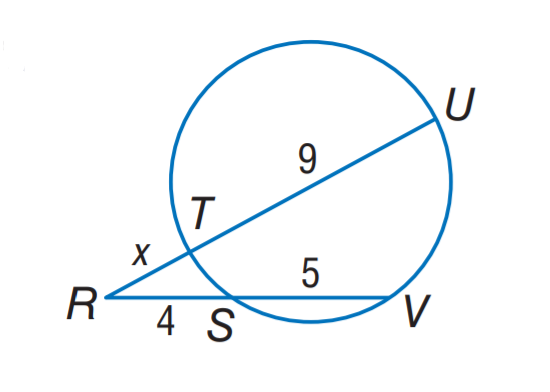Answer the mathemtical geometry problem and directly provide the correct option letter.
Question: Find x.
Choices: A: 2 B: 3 C: 4 D: 5 B 